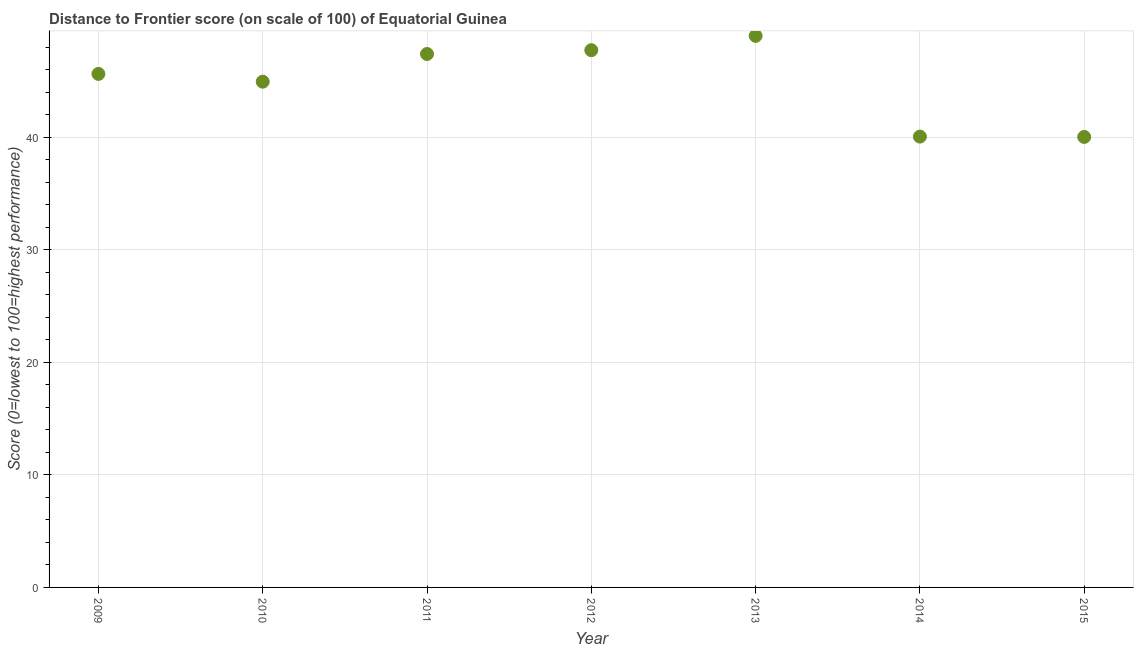What is the distance to frontier score in 2009?
Offer a terse response. 45.63. Across all years, what is the maximum distance to frontier score?
Provide a succinct answer. 49.01. Across all years, what is the minimum distance to frontier score?
Ensure brevity in your answer.  40.03. In which year was the distance to frontier score minimum?
Your answer should be compact. 2015. What is the sum of the distance to frontier score?
Your answer should be compact. 314.81. What is the difference between the distance to frontier score in 2009 and 2012?
Keep it short and to the point. -2.11. What is the average distance to frontier score per year?
Give a very brief answer. 44.97. What is the median distance to frontier score?
Offer a terse response. 45.63. Do a majority of the years between 2012 and 2013 (inclusive) have distance to frontier score greater than 36 ?
Offer a very short reply. Yes. What is the ratio of the distance to frontier score in 2012 to that in 2013?
Make the answer very short. 0.97. Is the difference between the distance to frontier score in 2009 and 2013 greater than the difference between any two years?
Your response must be concise. No. What is the difference between the highest and the second highest distance to frontier score?
Provide a short and direct response. 1.27. What is the difference between the highest and the lowest distance to frontier score?
Offer a terse response. 8.98. In how many years, is the distance to frontier score greater than the average distance to frontier score taken over all years?
Offer a very short reply. 4. How many dotlines are there?
Give a very brief answer. 1. What is the difference between two consecutive major ticks on the Y-axis?
Give a very brief answer. 10. Are the values on the major ticks of Y-axis written in scientific E-notation?
Offer a terse response. No. Does the graph contain any zero values?
Your answer should be very brief. No. What is the title of the graph?
Your response must be concise. Distance to Frontier score (on scale of 100) of Equatorial Guinea. What is the label or title of the X-axis?
Make the answer very short. Year. What is the label or title of the Y-axis?
Keep it short and to the point. Score (0=lowest to 100=highest performance). What is the Score (0=lowest to 100=highest performance) in 2009?
Offer a very short reply. 45.63. What is the Score (0=lowest to 100=highest performance) in 2010?
Give a very brief answer. 44.94. What is the Score (0=lowest to 100=highest performance) in 2011?
Provide a short and direct response. 47.4. What is the Score (0=lowest to 100=highest performance) in 2012?
Your response must be concise. 47.74. What is the Score (0=lowest to 100=highest performance) in 2013?
Make the answer very short. 49.01. What is the Score (0=lowest to 100=highest performance) in 2014?
Give a very brief answer. 40.06. What is the Score (0=lowest to 100=highest performance) in 2015?
Your response must be concise. 40.03. What is the difference between the Score (0=lowest to 100=highest performance) in 2009 and 2010?
Provide a succinct answer. 0.69. What is the difference between the Score (0=lowest to 100=highest performance) in 2009 and 2011?
Ensure brevity in your answer.  -1.77. What is the difference between the Score (0=lowest to 100=highest performance) in 2009 and 2012?
Offer a very short reply. -2.11. What is the difference between the Score (0=lowest to 100=highest performance) in 2009 and 2013?
Your answer should be very brief. -3.38. What is the difference between the Score (0=lowest to 100=highest performance) in 2009 and 2014?
Provide a succinct answer. 5.57. What is the difference between the Score (0=lowest to 100=highest performance) in 2009 and 2015?
Your answer should be compact. 5.6. What is the difference between the Score (0=lowest to 100=highest performance) in 2010 and 2011?
Provide a succinct answer. -2.46. What is the difference between the Score (0=lowest to 100=highest performance) in 2010 and 2012?
Your answer should be very brief. -2.8. What is the difference between the Score (0=lowest to 100=highest performance) in 2010 and 2013?
Offer a terse response. -4.07. What is the difference between the Score (0=lowest to 100=highest performance) in 2010 and 2014?
Ensure brevity in your answer.  4.88. What is the difference between the Score (0=lowest to 100=highest performance) in 2010 and 2015?
Your answer should be compact. 4.91. What is the difference between the Score (0=lowest to 100=highest performance) in 2011 and 2012?
Give a very brief answer. -0.34. What is the difference between the Score (0=lowest to 100=highest performance) in 2011 and 2013?
Provide a short and direct response. -1.61. What is the difference between the Score (0=lowest to 100=highest performance) in 2011 and 2014?
Offer a terse response. 7.34. What is the difference between the Score (0=lowest to 100=highest performance) in 2011 and 2015?
Offer a very short reply. 7.37. What is the difference between the Score (0=lowest to 100=highest performance) in 2012 and 2013?
Give a very brief answer. -1.27. What is the difference between the Score (0=lowest to 100=highest performance) in 2012 and 2014?
Offer a terse response. 7.68. What is the difference between the Score (0=lowest to 100=highest performance) in 2012 and 2015?
Provide a succinct answer. 7.71. What is the difference between the Score (0=lowest to 100=highest performance) in 2013 and 2014?
Provide a succinct answer. 8.95. What is the difference between the Score (0=lowest to 100=highest performance) in 2013 and 2015?
Your response must be concise. 8.98. What is the ratio of the Score (0=lowest to 100=highest performance) in 2009 to that in 2012?
Your answer should be compact. 0.96. What is the ratio of the Score (0=lowest to 100=highest performance) in 2009 to that in 2014?
Provide a succinct answer. 1.14. What is the ratio of the Score (0=lowest to 100=highest performance) in 2009 to that in 2015?
Your response must be concise. 1.14. What is the ratio of the Score (0=lowest to 100=highest performance) in 2010 to that in 2011?
Keep it short and to the point. 0.95. What is the ratio of the Score (0=lowest to 100=highest performance) in 2010 to that in 2012?
Provide a succinct answer. 0.94. What is the ratio of the Score (0=lowest to 100=highest performance) in 2010 to that in 2013?
Offer a terse response. 0.92. What is the ratio of the Score (0=lowest to 100=highest performance) in 2010 to that in 2014?
Your response must be concise. 1.12. What is the ratio of the Score (0=lowest to 100=highest performance) in 2010 to that in 2015?
Your response must be concise. 1.12. What is the ratio of the Score (0=lowest to 100=highest performance) in 2011 to that in 2012?
Make the answer very short. 0.99. What is the ratio of the Score (0=lowest to 100=highest performance) in 2011 to that in 2013?
Give a very brief answer. 0.97. What is the ratio of the Score (0=lowest to 100=highest performance) in 2011 to that in 2014?
Offer a very short reply. 1.18. What is the ratio of the Score (0=lowest to 100=highest performance) in 2011 to that in 2015?
Provide a succinct answer. 1.18. What is the ratio of the Score (0=lowest to 100=highest performance) in 2012 to that in 2013?
Provide a short and direct response. 0.97. What is the ratio of the Score (0=lowest to 100=highest performance) in 2012 to that in 2014?
Give a very brief answer. 1.19. What is the ratio of the Score (0=lowest to 100=highest performance) in 2012 to that in 2015?
Keep it short and to the point. 1.19. What is the ratio of the Score (0=lowest to 100=highest performance) in 2013 to that in 2014?
Your answer should be very brief. 1.22. What is the ratio of the Score (0=lowest to 100=highest performance) in 2013 to that in 2015?
Make the answer very short. 1.22. What is the ratio of the Score (0=lowest to 100=highest performance) in 2014 to that in 2015?
Your response must be concise. 1. 